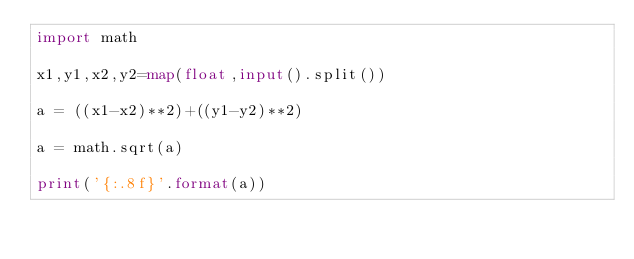<code> <loc_0><loc_0><loc_500><loc_500><_Python_>import math

x1,y1,x2,y2=map(float,input().split())

a = ((x1-x2)**2)+((y1-y2)**2)

a = math.sqrt(a)

print('{:.8f}'.format(a))
</code> 